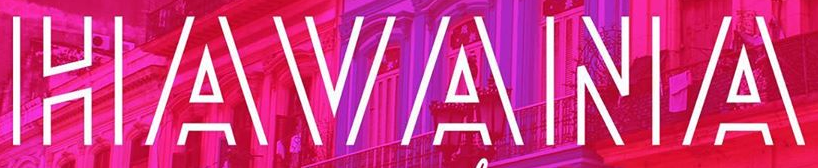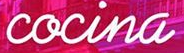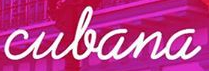Read the text content from these images in order, separated by a semicolon. HAVANA; cocina; culana 